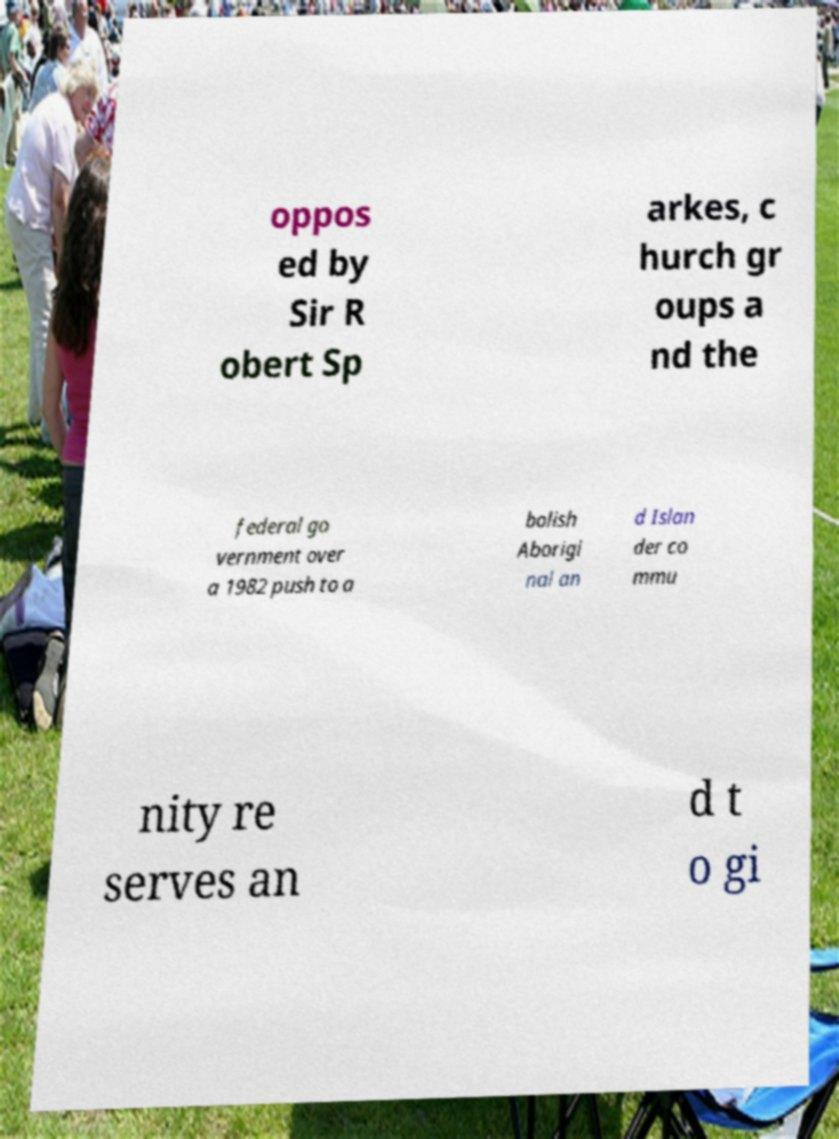Could you extract and type out the text from this image? oppos ed by Sir R obert Sp arkes, c hurch gr oups a nd the federal go vernment over a 1982 push to a bolish Aborigi nal an d Islan der co mmu nity re serves an d t o gi 